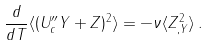<formula> <loc_0><loc_0><loc_500><loc_500>\frac { d } { d T } \langle ( U ^ { \prime \prime } _ { c } Y + Z ) ^ { 2 } \rangle = - \nu \langle Z _ { , Y } ^ { 2 } \rangle \, .</formula> 